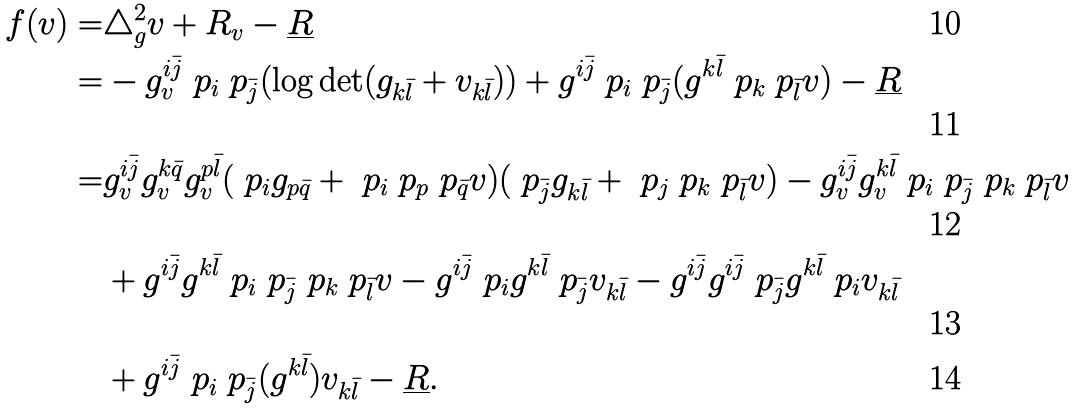<formula> <loc_0><loc_0><loc_500><loc_500>f ( v ) = & \triangle _ { g } ^ { 2 } v + R _ { v } - \underline { R } \\ = & - { g ^ { i \bar { j } } _ { v } } \ p _ { i } \ p _ { \bar { j } } ( \log { \det ( g _ { k \bar { l } } + v _ { k \bar { l } } ) } ) + g ^ { i \bar { j } } \ p _ { i } \ p _ { \bar { j } } ( g ^ { k \bar { l } } \ p _ { k } \ p _ { \bar { l } } v ) - \underline { R } \\ = & g ^ { i \bar { j } } _ { v } g ^ { k \bar { q } } _ { v } g ^ { p \bar { l } } _ { v } ( \ p _ { i } g _ { p \bar { q } } + \ p _ { i } \ p _ { p } \ p _ { \bar { q } } v ) ( \ p _ { \bar { j } } g _ { k \bar { l } } + \ p _ { j } \ p _ { k } \ p _ { \bar { l } } v ) - g ^ { i \bar { j } } _ { v } g ^ { k \bar { l } } _ { v } \ p _ { i } \ p _ { \bar { j } } \ p _ { k } \ p _ { \bar { l } } v \\ & + g ^ { i \bar { j } } g ^ { k \bar { l } } \ p _ { i } \ p _ { \bar { j } } \ p _ { k } \ p _ { \bar { l } } v - g ^ { i \bar { j } } \ p _ { i } g ^ { k \bar { l } } \ p _ { \bar { j } } v _ { k \bar { l } } - g ^ { i \bar { j } } g ^ { i \bar { j } } \ p _ { \bar { j } } g ^ { k \bar { l } } \ p _ { i } v _ { k \bar { l } } \\ & + g ^ { i \bar { j } } \ p _ { i } \ p _ { \bar { j } } ( g ^ { k \bar { l } } ) v _ { k \bar { l } } - \underline { R } .</formula> 